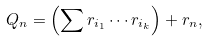<formula> <loc_0><loc_0><loc_500><loc_500>Q _ { n } = \left ( \sum r _ { i _ { 1 } } \cdots r _ { i _ { k } } \right ) + r _ { n } ,</formula> 